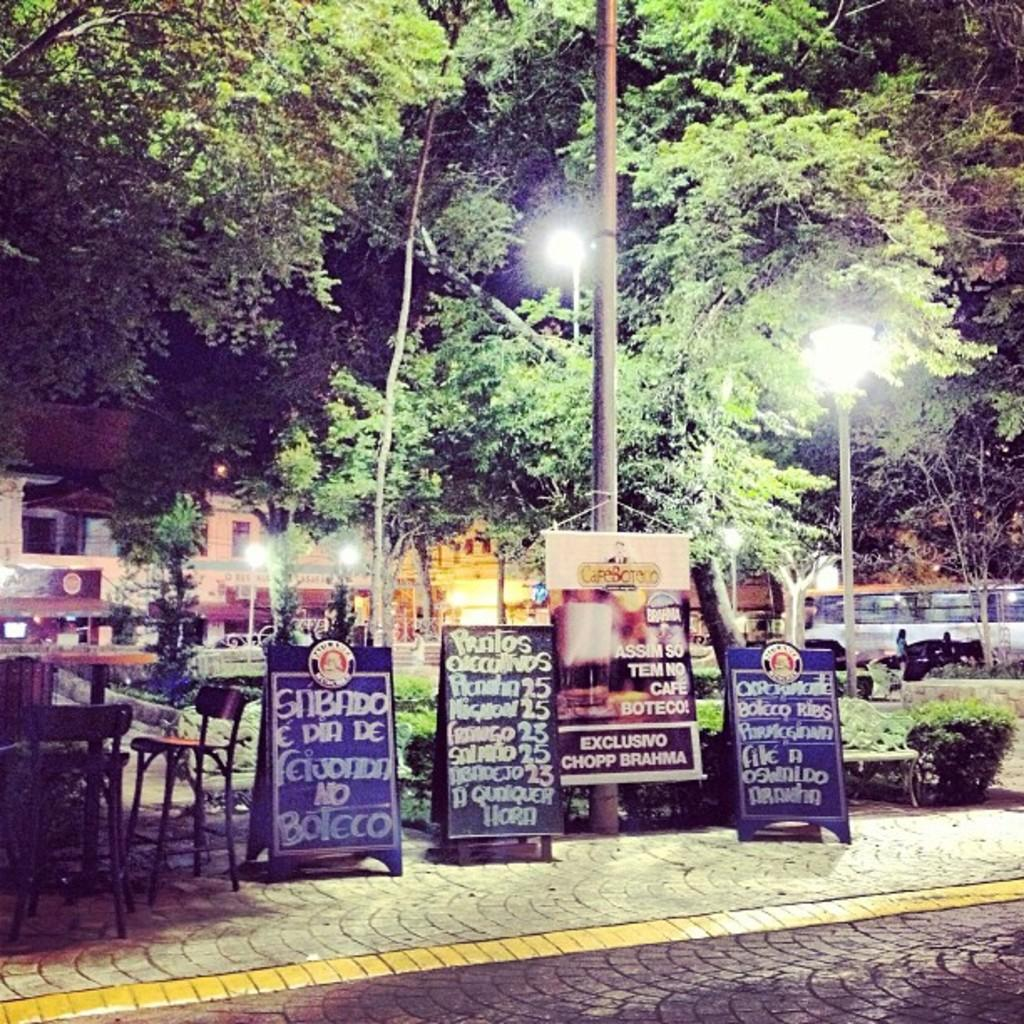What objects are located in the middle of the image? In the middle of the image, there are banners, chairs, tables, plants, and poles. Can you describe the background of the image? In the background of the image, there are trees and buildings visible. What type of objects are present in the middle of the image that might be used for seating? Chairs are present in the middle of the image for seating. What type of objects are present in the middle of the image that might be used for displaying information? Banners are present in the middle of the image for displaying information. What type of soup is being served in the image? There is no soup present in the image. What type of comb is being used to style the plants in the image? There is no comb present in the image, and the plants are not being styled. 